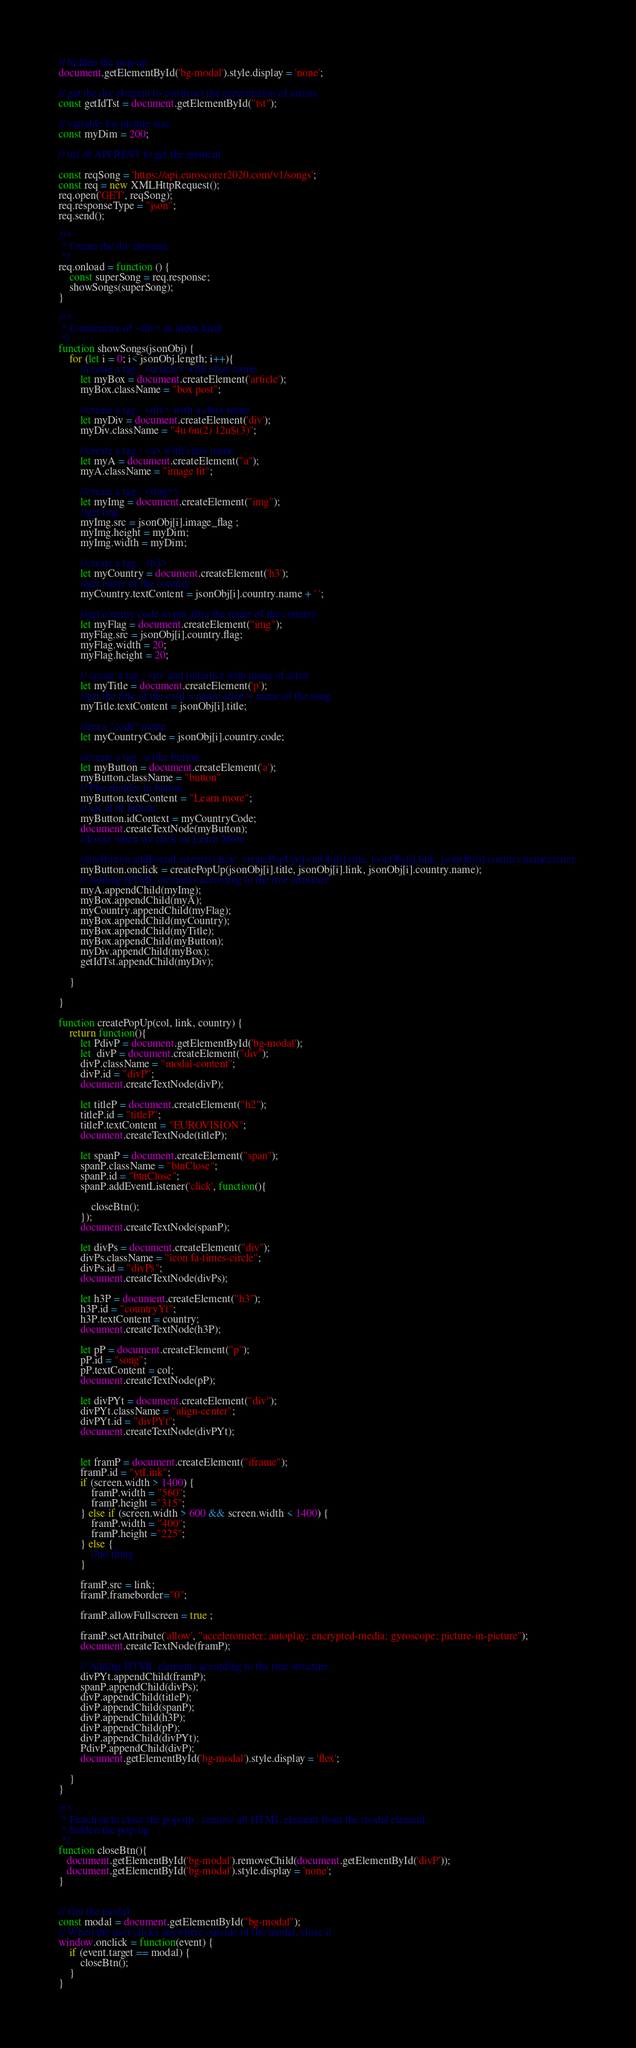<code> <loc_0><loc_0><loc_500><loc_500><_JavaScript_>// hidden the pop-up
document.getElementById('bg-modal').style.display = 'none';

// get the div element to construct the presentation of artists
const getIdTst = document.getElementById("tst");

// variable for picture size
const myDim = 200;

// url of API REST to get the element

const reqSong = 'https://api.euroscorer2020.com/v1/songs';
const req = new XMLHttpRequest();
req.open('GET', reqSong);
req.responseType = "json";
req.send();

/**
 * Create the div element
 */
req.onload = function () {
    const superSong = req.response;
    showSongs(superSong); 
}

/**
 * Constructor of <div> in index.html
 */
function showSongs(jsonObj) {
    for (let i = 0; i< jsonObj.length; i++){
        //create a tag : <article> with class name
        let myBox = document.createElement('article');
        myBox.className = "box post";

        //create a tag : <div> with a class name
        let myDiv = document.createElement('div');
        myDiv.className = "4u 6u(2) 12u$(3)";

        //create a tag : <a> with class name
        let myA = document.createElement("a");
        myA.className = "image fit";

        //create a tag : <img>>
        let myImg = document.createElement("img");
        //get img
        myImg.src = jsonObj[i].image_flag ;
        myImg.height = myDim;
        myImg.width = myDim;

        //create a tag : <h3>
        let myCountry = document.createElement('h3');
        //get name of the country
        myCountry.textContent = jsonObj[i].country.name + ' ';

        //get country code to put after the name of the country
        let myFlag = document.createElement("img");
        myFlag.src = jsonObj[i].country.flag;
        myFlag.width = 20;
        myFlag.height = 20;

        // create a tag : <p> and initialise with name of artist
        let myTitle = document.createElement('p');
        //get the title of the card = name artist + name of the song
        myTitle.textContent = jsonObj[i].title;

        //get a "code" name
        let myCountryCode = jsonObj[i].country.code;

        //create a tag : a like button
        let myButton = document.createElement('a');
        myButton.className = "button"
        // Placeholder in button
        myButton.textContent = "Learn more";
        // set id of button
        myButton.idContext = myCountryCode;
        document.createTextNode(myButton);
        //Event when we click on Learn More

        //myButton.addEventListener('click', createPopUp(jsonObj[i].title, jsonObj[i].link, jsonObj[i].country.name),true);
        myButton.onclick = createPopUp(jsonObj[i].title, jsonObj[i].link, jsonObj[i].country.name);
        // Adding HTML elements according to the tree structure
        myA.appendChild(myImg);
        myBox.appendChild(myA);
        myCountry.appendChild(myFlag);
        myBox.appendChild(myCountry);
        myBox.appendChild(myTitle);
        myBox.appendChild(myButton);
        myDiv.appendChild(myBox);
        getIdTst.appendChild(myDiv);

    }

}

function createPopUp(col, link, country) {
    return function(){
        let PdivP = document.getElementById('bg-modal');
        let  divP = document.createElement("div");
        divP.className = "modal-content";
        divP.id = "divP";
        document.createTextNode(divP);

        let titleP = document.createElement("h2");
        titleP.id = "titleP";
        titleP.textContent = "EUROVISION";
        document.createTextNode(titleP);

        let spanP = document.createElement("span");
        spanP.className = "btnClose";
        spanP.id = "btnClose";
        spanP.addEventListener('click', function(){

            closeBtn();
        });
        document.createTextNode(spanP);

        let divPs = document.createElement("div");
        divPs.className = "icon fa-times-circle";
        divPs.id = "divPs";
        document.createTextNode(divPs);

        let h3P = document.createElement("h3");
        h3P.id = "countryYt";
        h3P.textContent = country;
        document.createTextNode(h3P);

        let pP = document.createElement("p");
        pP.id = "song";
        pP.textContent = col;
        document.createTextNode(pP);

        let divPYt = document.createElement("div");
        divPYt.className = "align-center";
        divPYt.id = "divPYt";
        document.createTextNode(divPYt);


        let framP = document.createElement("iframe");
        framP.id = "ytLink";
        if (screen.width > 1400) {
            framP.width = "560";
            framP.height ="315";
        } else if (screen.width > 600 && screen.width < 1400) {
            framP.width = "400";
            framP.height ="225";
        } else {
            //no thing
        }

        framP.src = link;
        framP.frameborder="0";

        framP.allowFullscreen = true ;

        framP.setAttribute('allow', "accelerometer; autoplay; encrypted-media; gyroscope; picture-in-picture");
        document.createTextNode(framP);

        // Adding HTML elements according to the tree structure
        divPYt.appendChild(framP);
        spanP.appendChild(divPs);
        divP.appendChild(titleP);
        divP.appendChild(spanP);
        divP.appendChild(h3P);
        divP.appendChild(pP);
        divP.appendChild(divPYt);
        PdivP.appendChild(divP);
        document.getElementById('bg-modal').style.display = 'flex';

    }
}

/**
 * Function to close the pop-up : remove all HTML element from the modal element
 * hidden the pop-up
 */
function closeBtn(){
   document.getElementById('bg-modal').removeChild(document.getElementById('divP'));
   document.getElementById('bg-modal').style.display = 'none';
}


// Get the modal
const modal = document.getElementById("bg-modal");
// When the user clicks anywhere outside of the modal, close it
window.onclick = function(event) {
    if (event.target == modal) {
        closeBtn();
    }
}</code> 